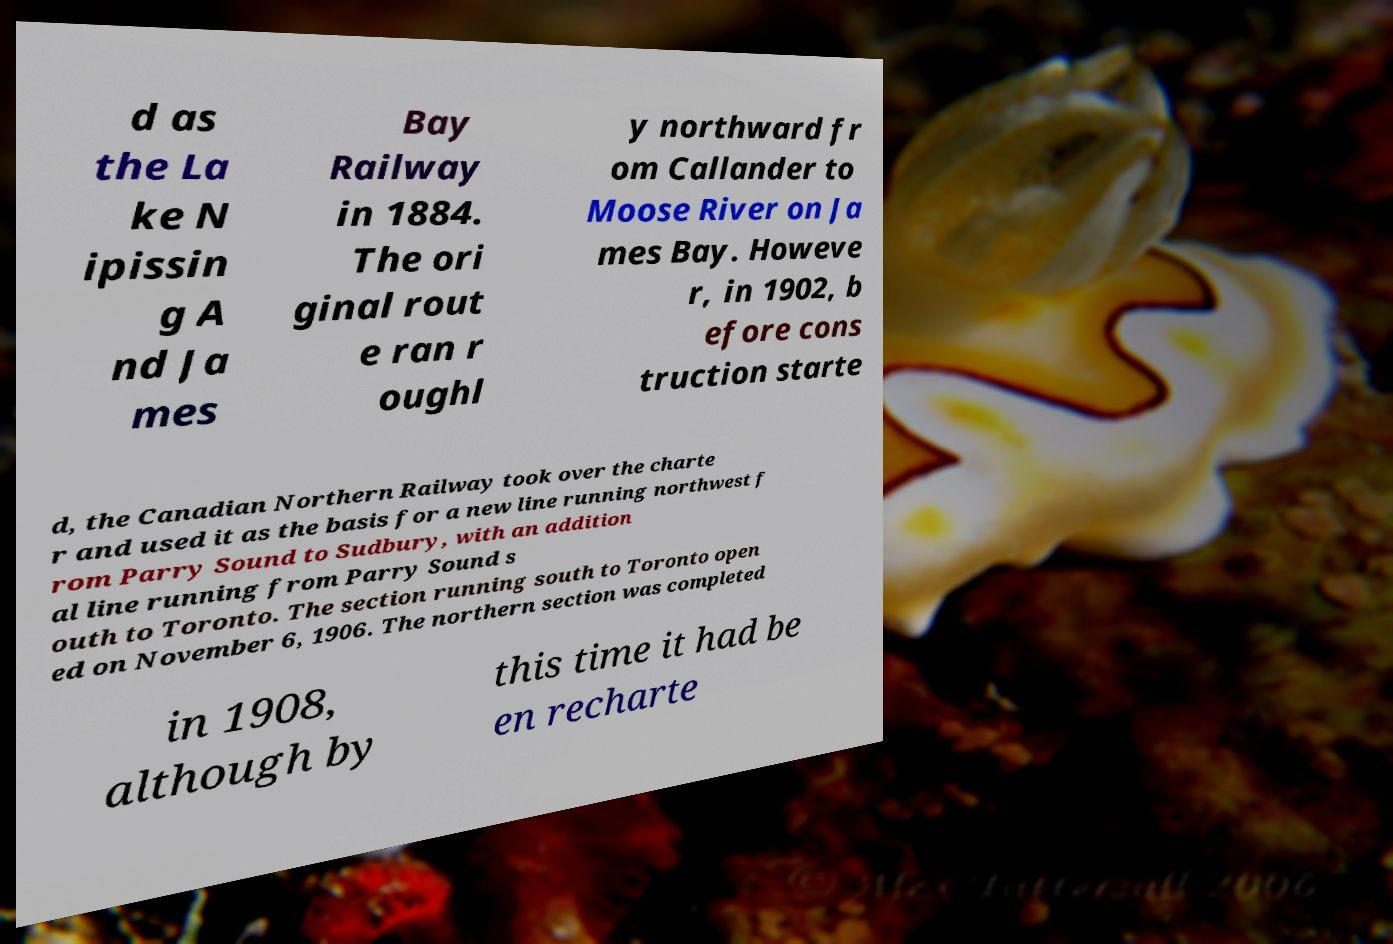For documentation purposes, I need the text within this image transcribed. Could you provide that? d as the La ke N ipissin g A nd Ja mes Bay Railway in 1884. The ori ginal rout e ran r oughl y northward fr om Callander to Moose River on Ja mes Bay. Howeve r, in 1902, b efore cons truction starte d, the Canadian Northern Railway took over the charte r and used it as the basis for a new line running northwest f rom Parry Sound to Sudbury, with an addition al line running from Parry Sound s outh to Toronto. The section running south to Toronto open ed on November 6, 1906. The northern section was completed in 1908, although by this time it had be en recharte 